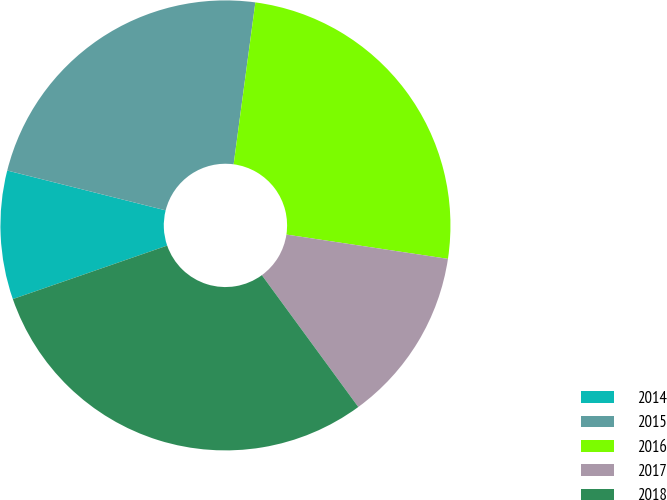Convert chart to OTSL. <chart><loc_0><loc_0><loc_500><loc_500><pie_chart><fcel>2014<fcel>2015<fcel>2016<fcel>2017<fcel>2018<nl><fcel>9.23%<fcel>23.2%<fcel>25.25%<fcel>12.57%<fcel>29.74%<nl></chart> 